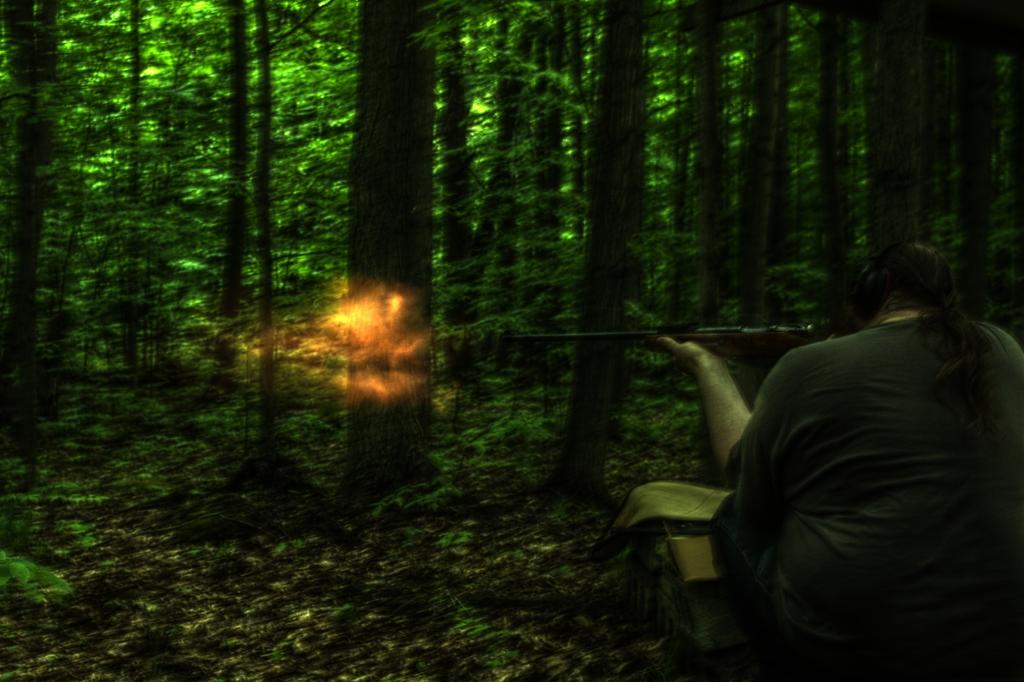What is the person in the image doing? The person is holding a gun and firing it. What can be seen in the background of the image? There are trees in the background of the image. What is present on the ground in the image? Dried leaves are present on the ground in the image. What type of tray is being used to catch the bullets in the image? There is no tray present in the image, and bullets are not being caught. 